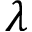Convert formula to latex. <formula><loc_0><loc_0><loc_500><loc_500>\lambda</formula> 